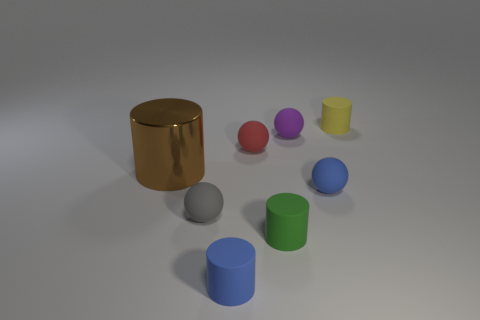Add 1 tiny purple spheres. How many objects exist? 9 Subtract 0 gray blocks. How many objects are left? 8 Subtract all small red rubber blocks. Subtract all tiny yellow objects. How many objects are left? 7 Add 2 yellow matte cylinders. How many yellow matte cylinders are left? 3 Add 3 gray spheres. How many gray spheres exist? 4 